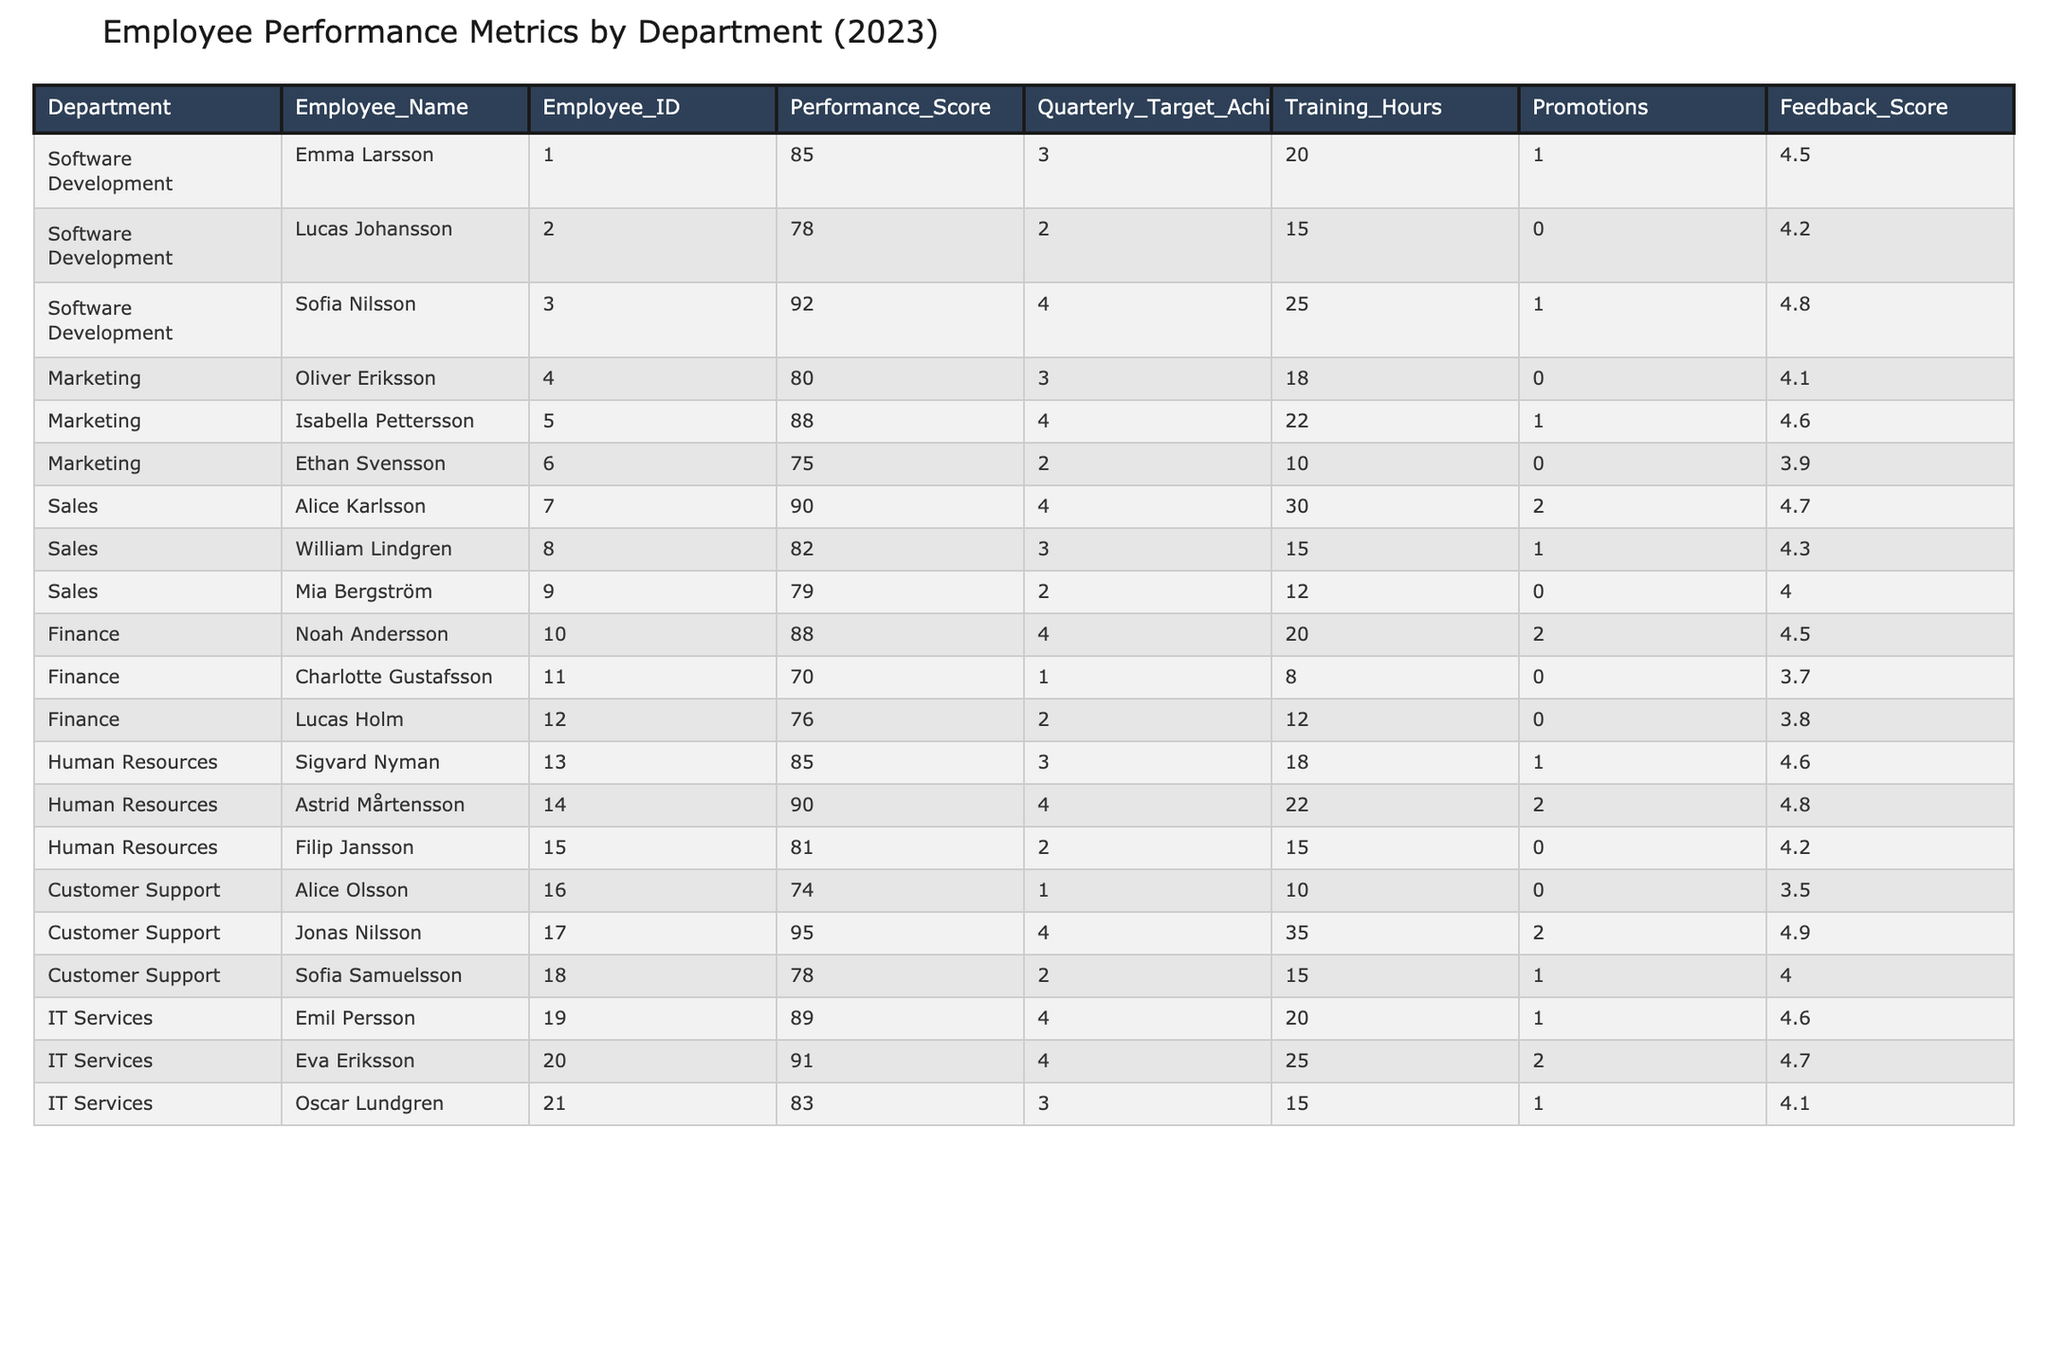What's the highest performance score in the table? Looking through the Performance_Score column, the highest value is 95, which belongs to Jonas Nilsson from the Customer Support department.
Answer: 95 Which department has the most promotions? By examining the Promotions column for each department, Sales has the highest total of 3 promotions (2 for Alice Karlsson and 1 for William Lindgren).
Answer: Sales What is the average feedback score for the Marketing department? The Marketing department has three employees with feedback scores of 4.1, 4.6, and 3.9. Summing these scores gives 4.1 + 4.6 + 3.9 = 12.6. Dividing by the number of employees (3) results in an average of 12.6 / 3 = 4.2.
Answer: 4.2 How many employees in Finance achieved their quarterly targets? There are three employees in Finance: Noah Andersson (4), Charlotte Gustafsson (1), and Lucas Holm (2). Out of these, 2 (Noah and Lucas) achieved their quarterly targets, leading to a total of 2 employees in Finance that met their targets.
Answer: 2 Which employee had the highest number of training hours? Comparing the Training_Hours column, Jonas Nilsson from Customer Support recorded the highest number of training hours with 35 hours.
Answer: 35 Is there any employee in IT Services who received no promotions? Looking at the Promotions column, Oscar Lundgren from IT Services has 0 promotions, confirming that there is at least one employee without any promotions.
Answer: Yes What is the difference in the average performance score between Software Development and Human Resources? The average performance score for Software Development is (85 + 78 + 92) / 3 = 85. The average for Human Resources is (85 + 90 + 81) / 3 = 85.33. The difference is 85.33 - 85 = 0.33.
Answer: 0.33 Which department had the lowest average performance score? Calculating the averages shows: Software Development (85), Marketing (81), Sales (83.67), Finance (78), Human Resources (85.33), and Customer Support (77.33). Customer Support has the lowest average score of 77.33.
Answer: Customer Support How many employees in the table have performance scores above 80? Counting the number of employees with performance scores above 80 yields 8 out of 12 employees, including all from Software Development, Sales, Finance, and two from Marketing.
Answer: 8 In which quarter did the employee with the highest feedback score work? The employee with the highest feedback score (4.9) is Jonas Nilsson from Customer Support. According to the table, he achieved this score while achieving 4 quarterly targets.
Answer: Customer Support (Quarterly Target: 4) 